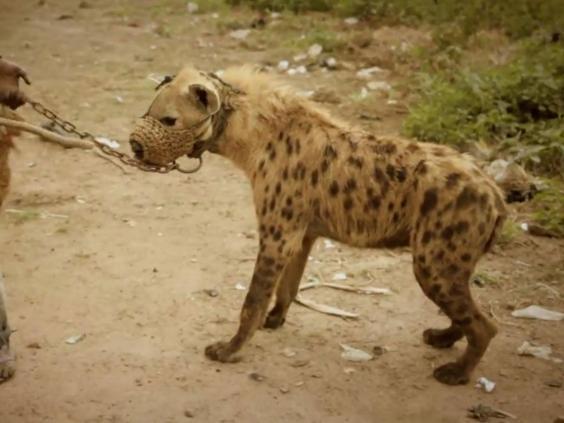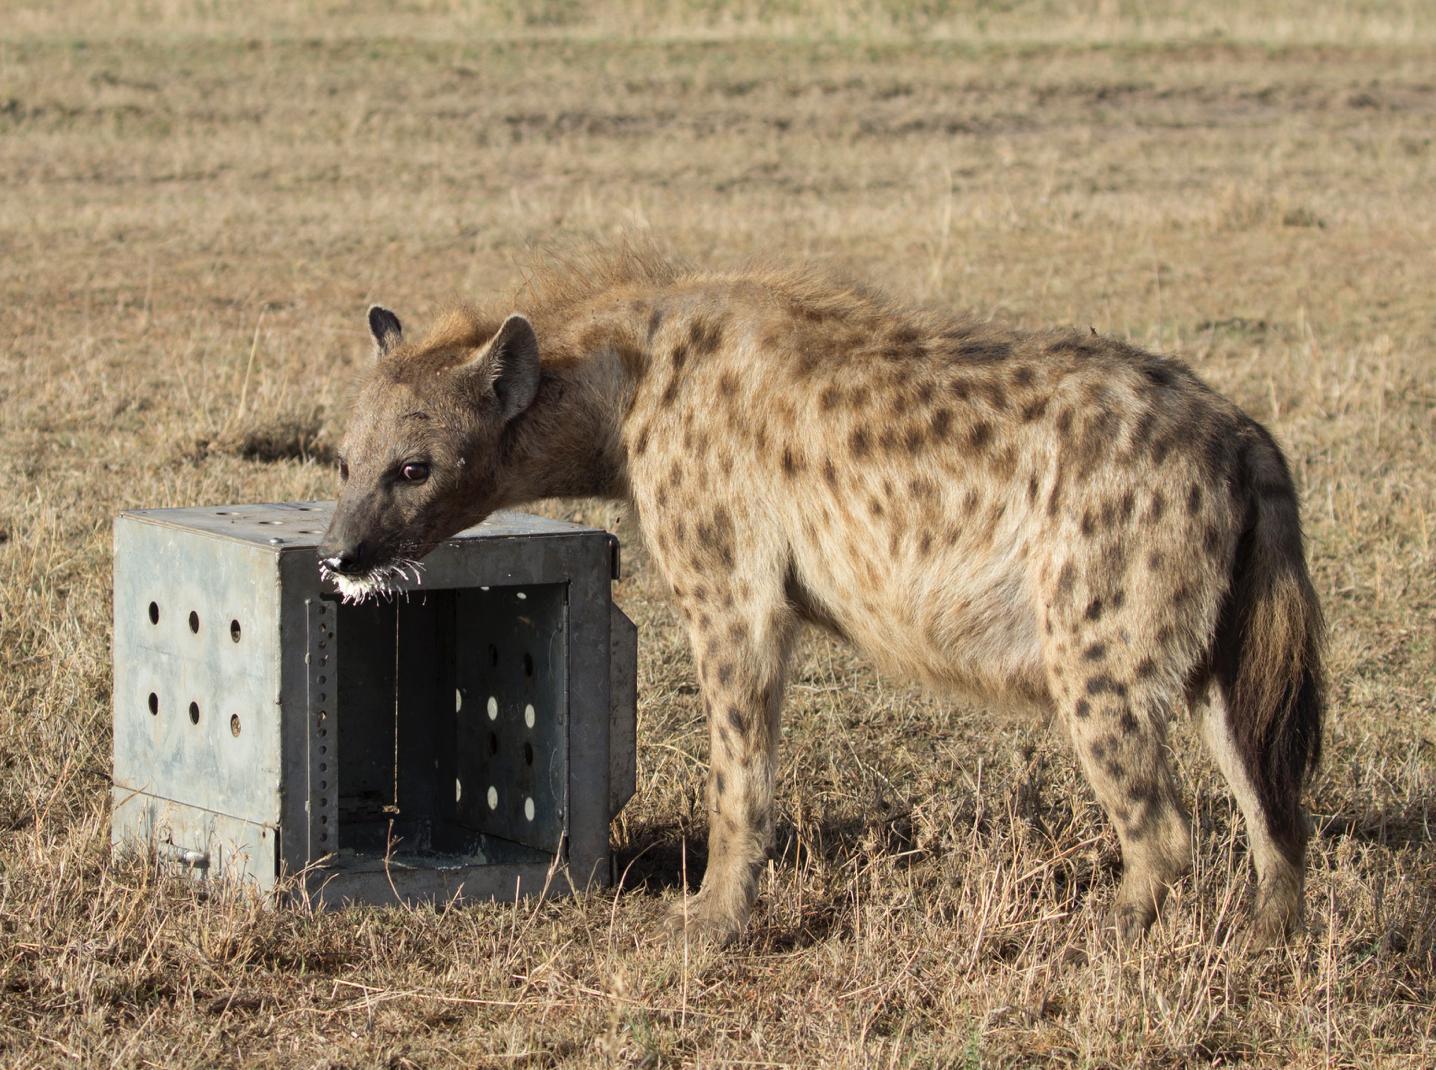The first image is the image on the left, the second image is the image on the right. Evaluate the accuracy of this statement regarding the images: "The right image contains exactly two hyenas.". Is it true? Answer yes or no. No. The first image is the image on the left, the second image is the image on the right. Assess this claim about the two images: "The hyena in the image on the left has something in its mouth.". Correct or not? Answer yes or no. Yes. 